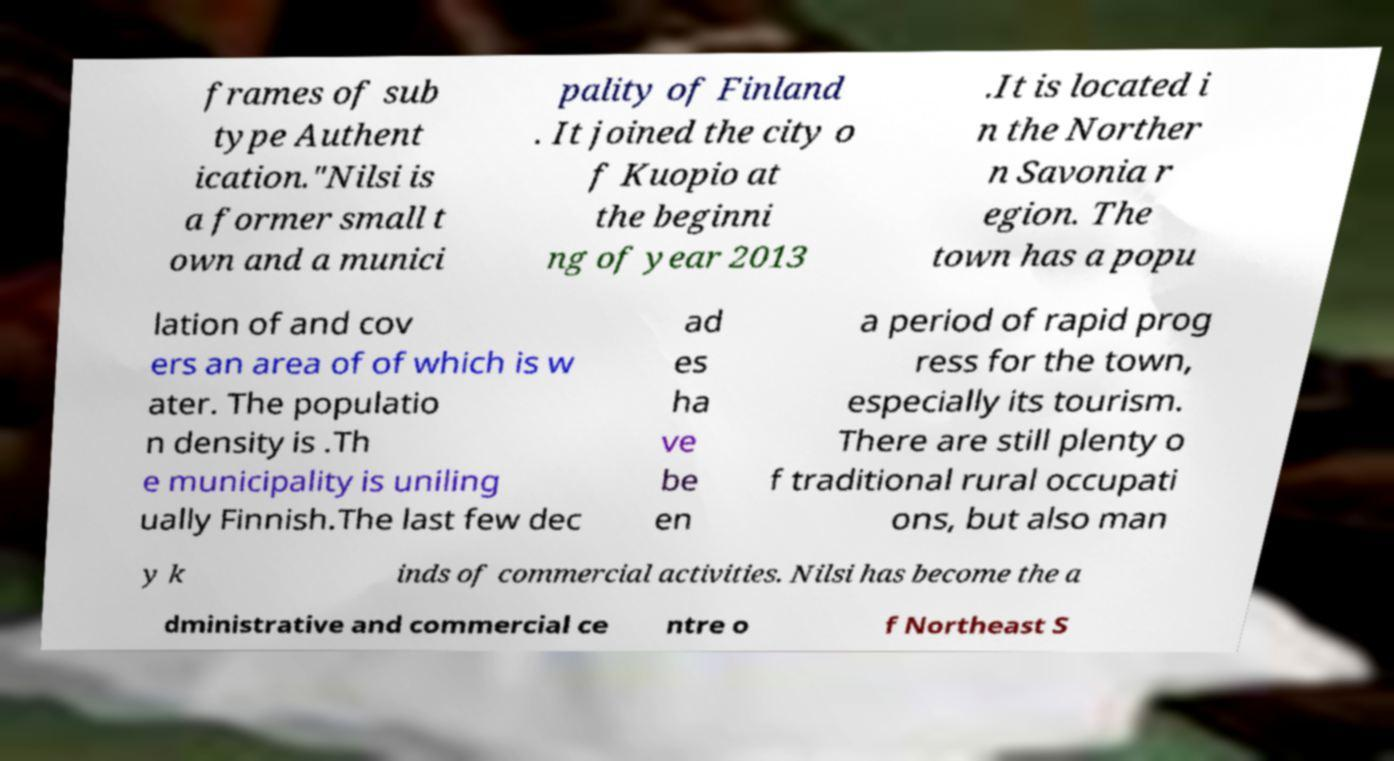For documentation purposes, I need the text within this image transcribed. Could you provide that? frames of sub type Authent ication."Nilsi is a former small t own and a munici pality of Finland . It joined the city o f Kuopio at the beginni ng of year 2013 .It is located i n the Norther n Savonia r egion. The town has a popu lation of and cov ers an area of of which is w ater. The populatio n density is .Th e municipality is uniling ually Finnish.The last few dec ad es ha ve be en a period of rapid prog ress for the town, especially its tourism. There are still plenty o f traditional rural occupati ons, but also man y k inds of commercial activities. Nilsi has become the a dministrative and commercial ce ntre o f Northeast S 